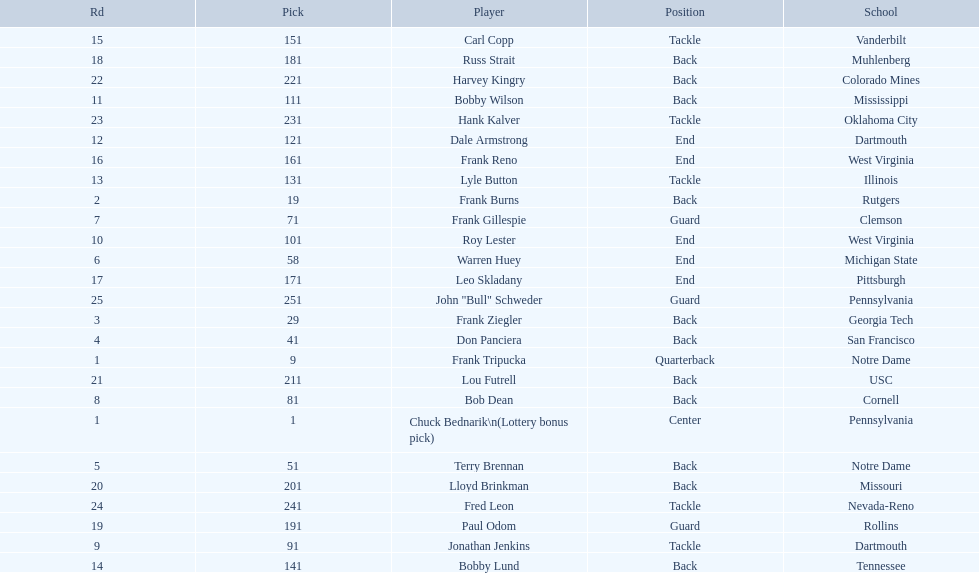Who was picked after frank burns? Frank Ziegler. 